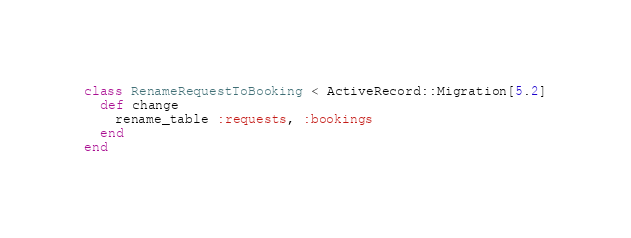<code> <loc_0><loc_0><loc_500><loc_500><_Ruby_>class RenameRequestToBooking < ActiveRecord::Migration[5.2]
  def change
    rename_table :requests, :bookings
  end
end
</code> 